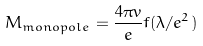Convert formula to latex. <formula><loc_0><loc_0><loc_500><loc_500>M _ { m o n o p o l e } = \frac { 4 \pi v } { e } f ( \lambda / e ^ { 2 } )</formula> 